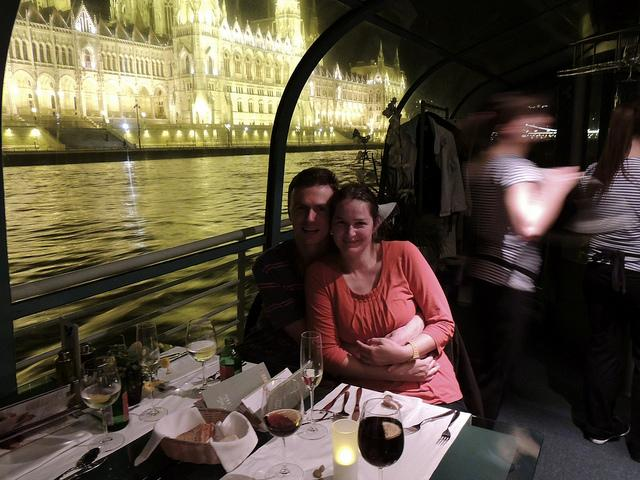Where is the couple most probably dining? Please explain your reasoning. boat. There is a body of water near the people, so they are likely on a boat. 